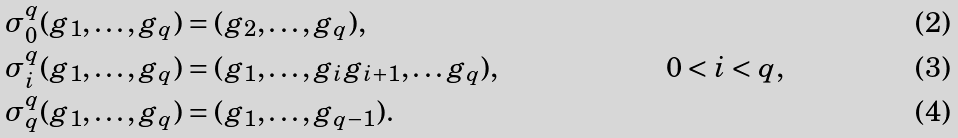<formula> <loc_0><loc_0><loc_500><loc_500>\sigma _ { 0 } ^ { q } ( g _ { 1 } , \dots , g _ { q } ) & = ( g _ { 2 } , \dots , g _ { q } ) , \\ \sigma _ { i } ^ { q } ( g _ { 1 } , \dots , g _ { q } ) & = ( g _ { 1 } , \dots , g _ { i } g _ { i + 1 } , \dots g _ { q } ) , & 0 < i < q , \\ \sigma _ { q } ^ { q } ( g _ { 1 } , \dots , g _ { q } ) & = ( g _ { 1 } , \dots , g _ { q - 1 } ) .</formula> 